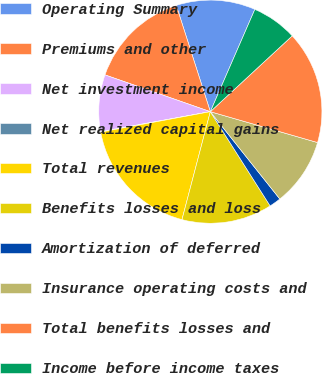<chart> <loc_0><loc_0><loc_500><loc_500><pie_chart><fcel>Operating Summary<fcel>Premiums and other<fcel>Net investment income<fcel>Net realized capital gains<fcel>Total revenues<fcel>Benefits losses and loss<fcel>Amortization of deferred<fcel>Insurance operating costs and<fcel>Total benefits losses and<fcel>Income before income taxes<nl><fcel>11.47%<fcel>14.72%<fcel>8.21%<fcel>0.07%<fcel>17.98%<fcel>13.09%<fcel>1.7%<fcel>9.84%<fcel>16.35%<fcel>6.58%<nl></chart> 